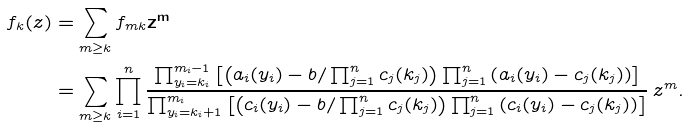Convert formula to latex. <formula><loc_0><loc_0><loc_500><loc_500>f _ { k } ( z ) & = \sum _ { m \geq k } f _ { m k } \mathbf z ^ { \mathbf m } \\ & = \sum _ { m \geq k } \prod _ { i = 1 } ^ { n } \frac { \prod _ { y _ { i } = k _ { i } } ^ { m _ { i } - 1 } \left [ \left ( a _ { i } ( y _ { i } ) - b / \prod _ { j = 1 } ^ { n } c _ { j } ( k _ { j } ) \right ) \prod _ { j = 1 } ^ { n } \left ( a _ { i } ( y _ { i } ) - c _ { j } ( k _ { j } ) \right ) \right ] } { \prod _ { y _ { i } = k _ { i } + 1 } ^ { m _ { i } } \left [ \left ( c _ { i } ( y _ { i } ) - b / \prod _ { j = 1 } ^ { n } c _ { j } ( k _ { j } ) \right ) \prod _ { j = 1 } ^ { n } \left ( c _ { i } ( y _ { i } ) - c _ { j } ( k _ { j } ) \right ) \right ] } \, z ^ { m } .</formula> 